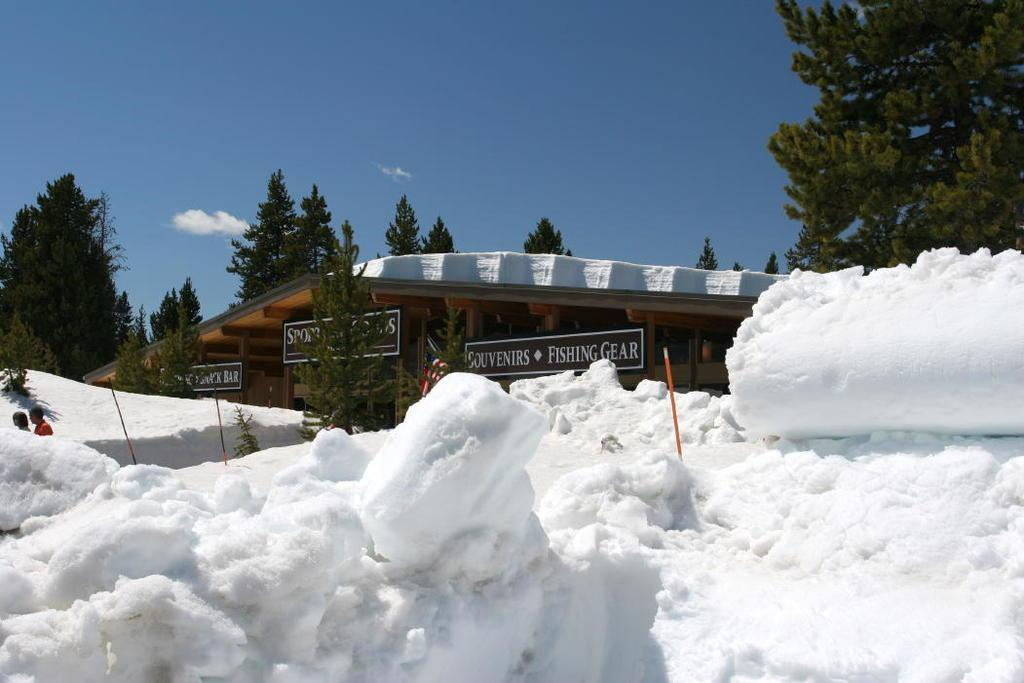What is covering the ground in the foreground of the image? There is snow in the foreground of the image. What structures are present on the snow? There are poles on the snow. What can be seen in the background of the image? There are trees and a shelter in the background of the image. What is visible in the sky in the background of the image? The sky is visible in the background of the image, and there are clouds in the sky. How many girls are using toothbrushes in the image? There are no girls or toothbrushes present in the image. 